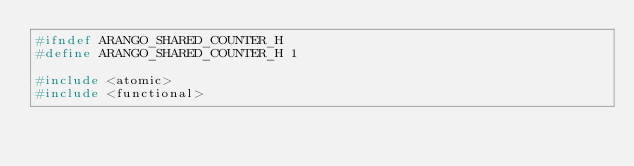Convert code to text. <code><loc_0><loc_0><loc_500><loc_500><_C_>#ifndef ARANGO_SHARED_COUNTER_H
#define ARANGO_SHARED_COUNTER_H 1

#include <atomic>
#include <functional>
</code> 